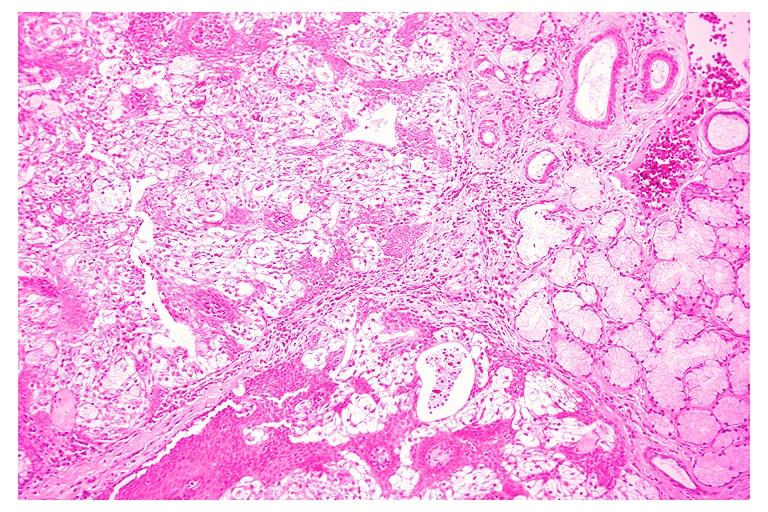what does this image show?
Answer the question using a single word or phrase. Mucoepidermoid carcinoma 